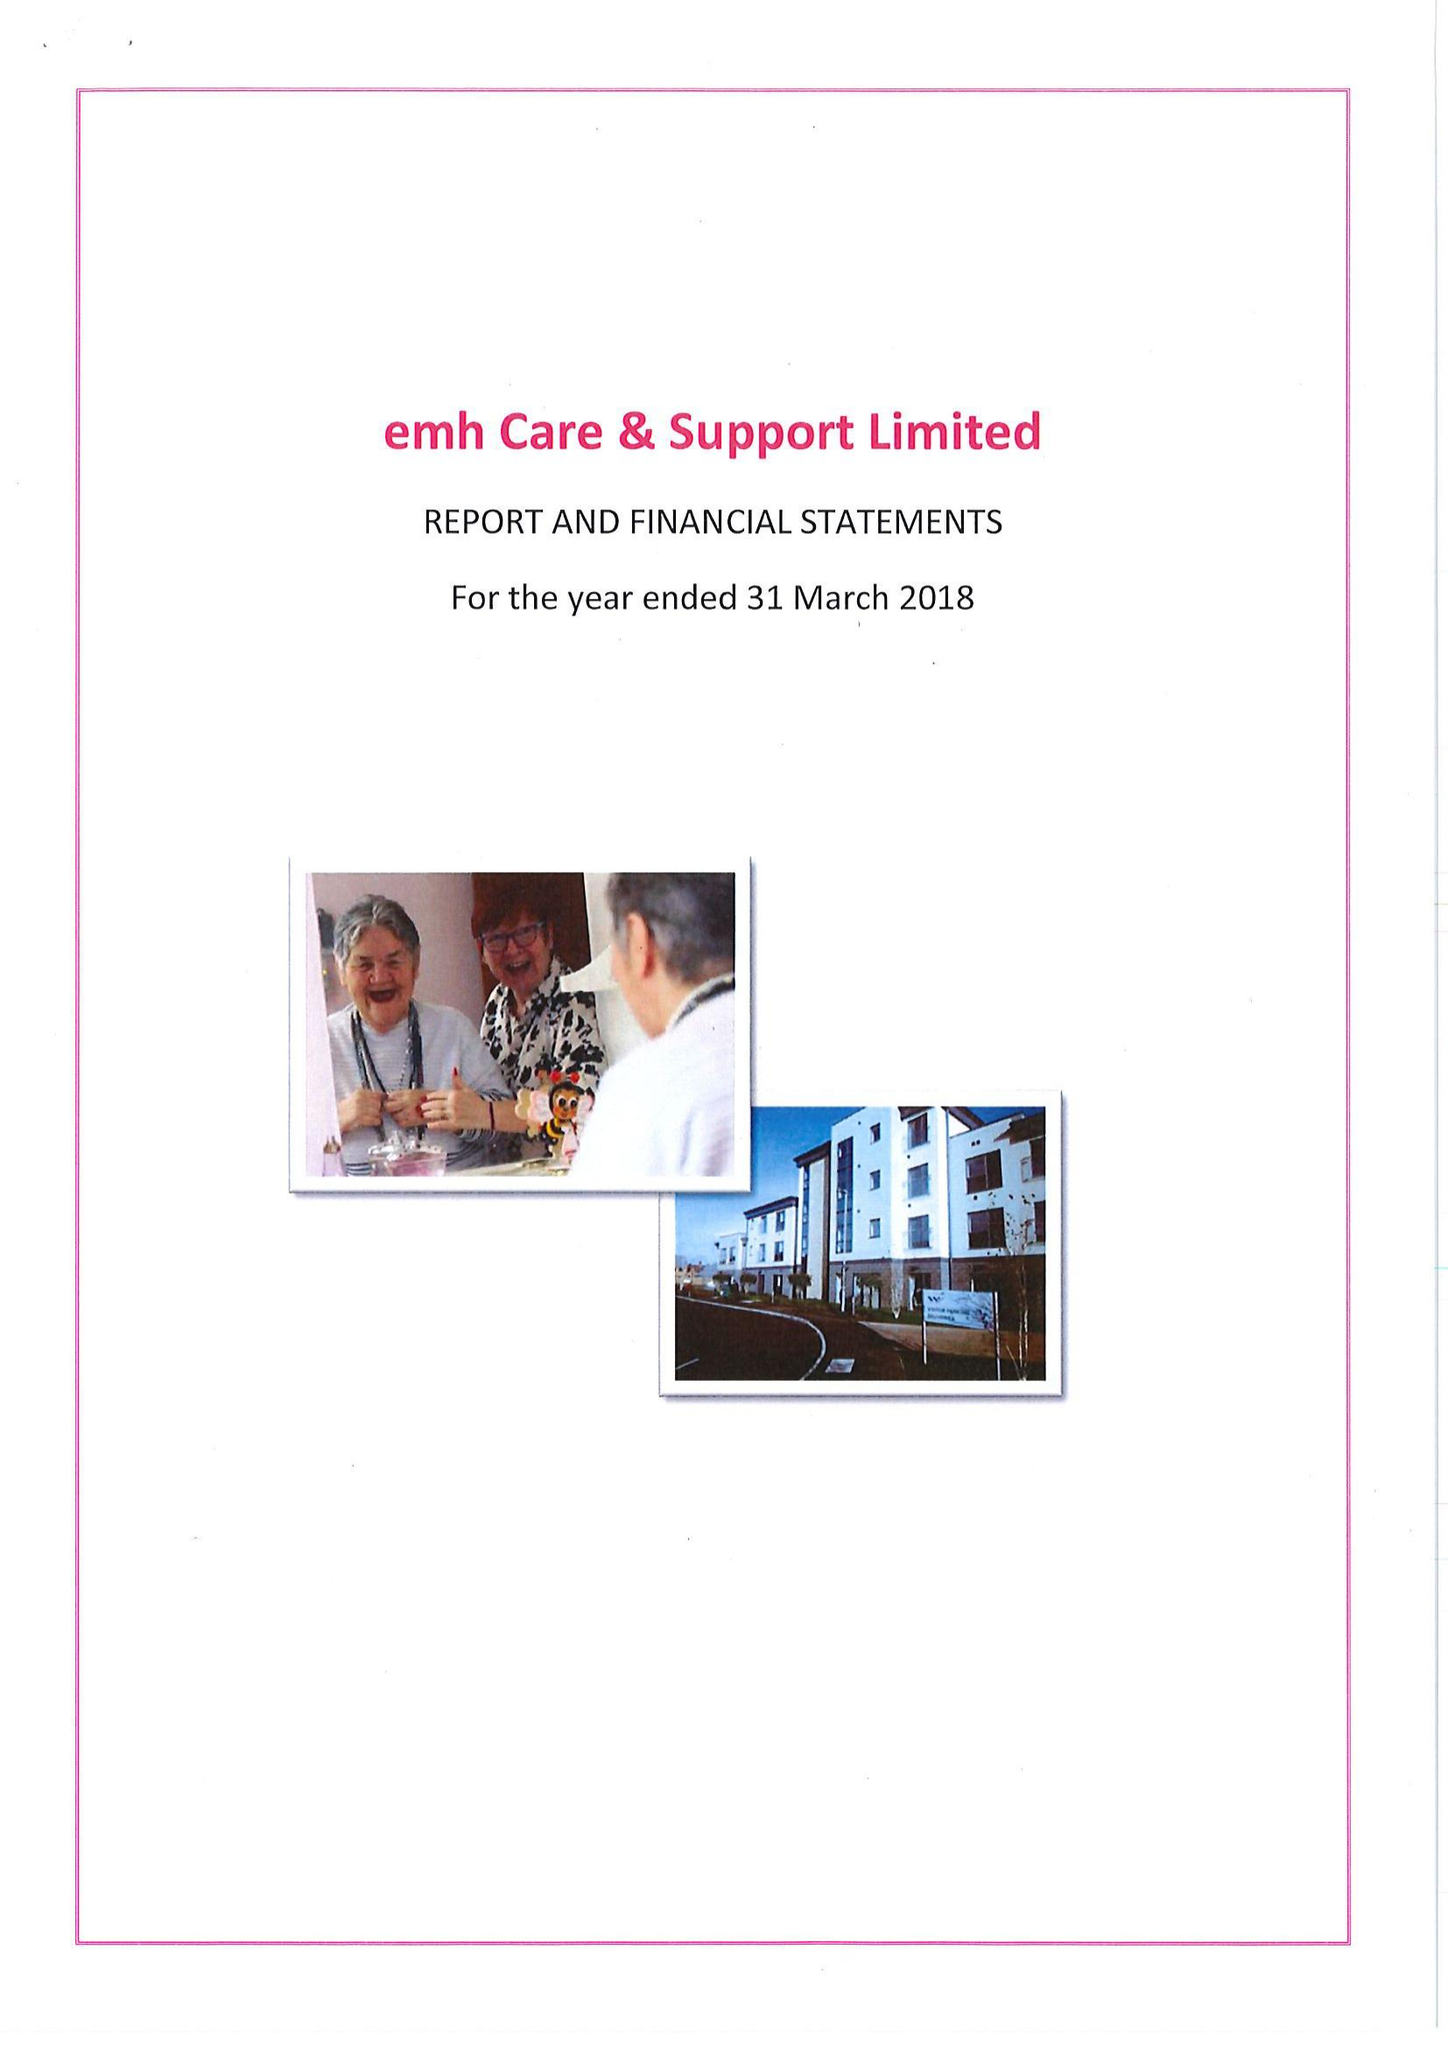What is the value for the address__post_town?
Answer the question using a single word or phrase. COALVILLE 